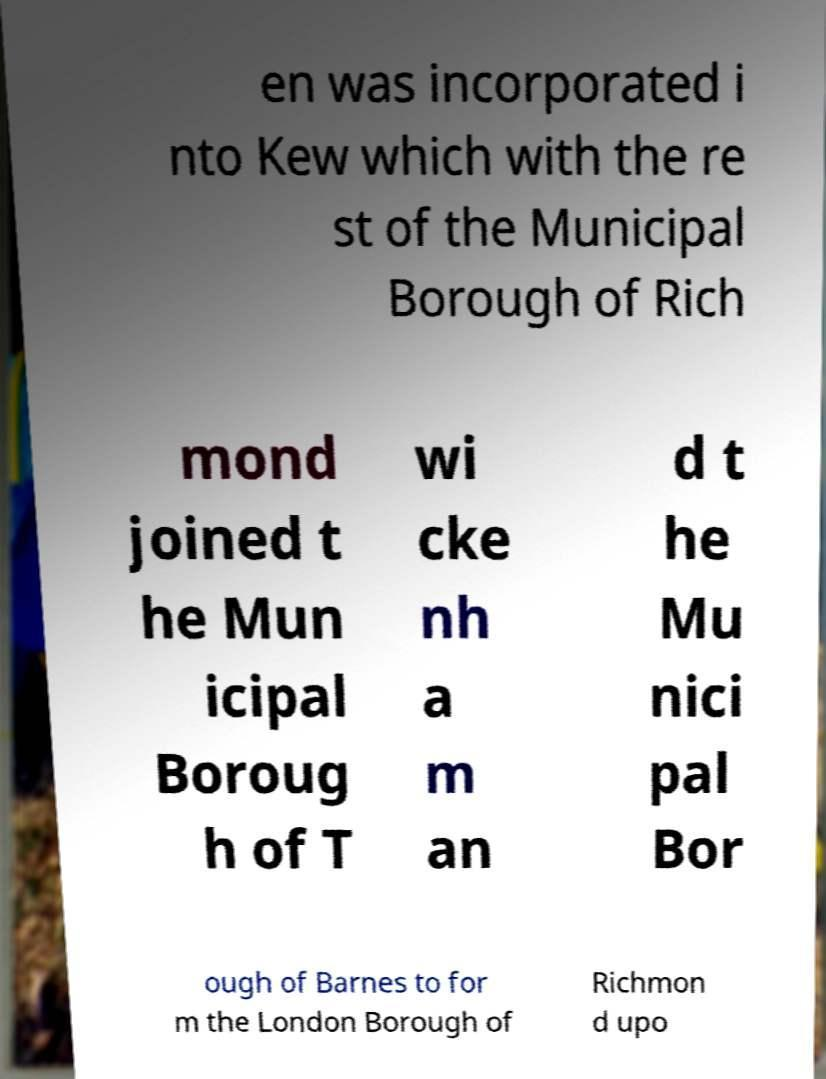Please identify and transcribe the text found in this image. en was incorporated i nto Kew which with the re st of the Municipal Borough of Rich mond joined t he Mun icipal Boroug h of T wi cke nh a m an d t he Mu nici pal Bor ough of Barnes to for m the London Borough of Richmon d upo 